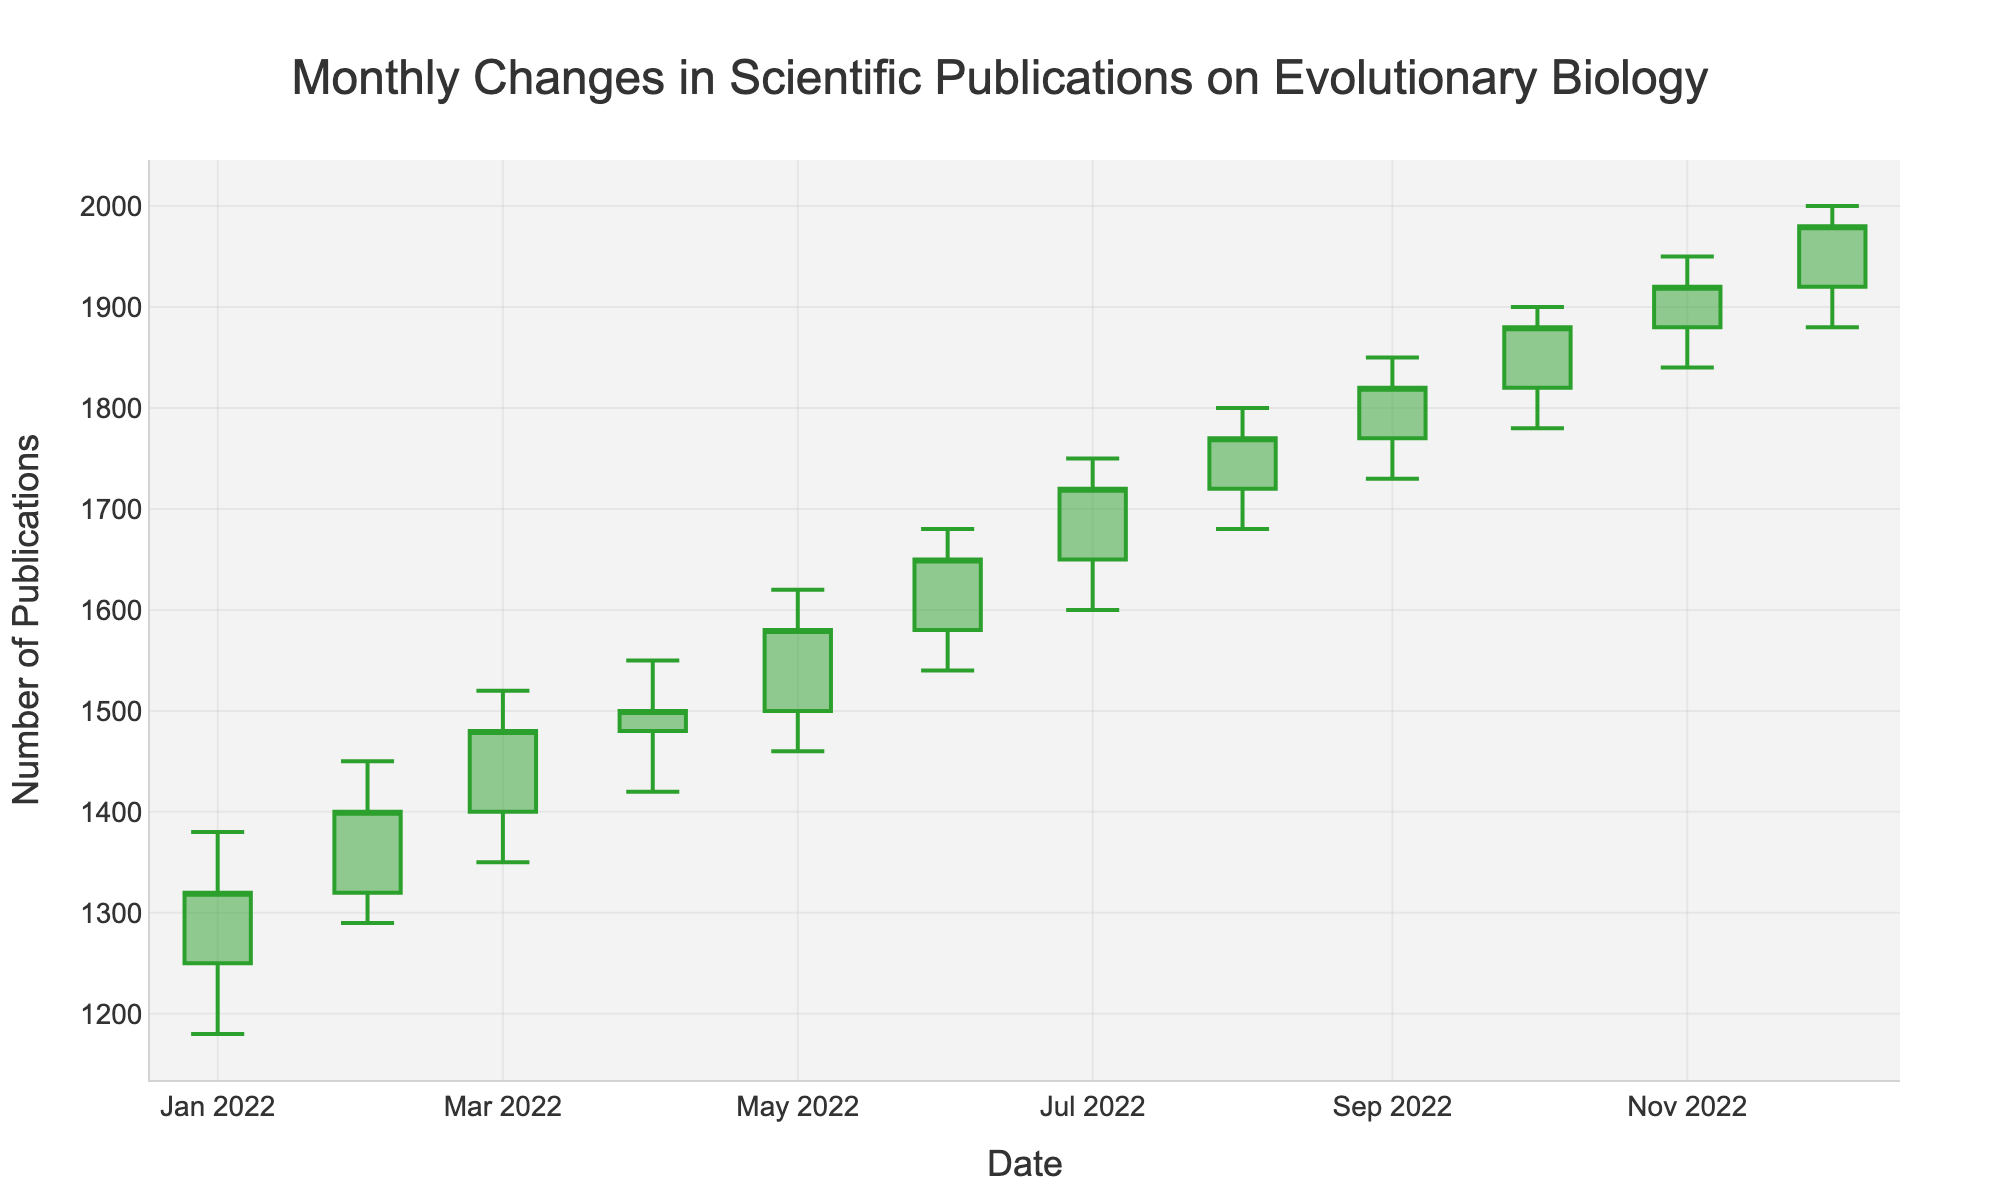How many data points are represented in the chart? The chart shows monthly changes for the year 2022. Since there are 12 months in a year and data for each month is represented, there are 12 data points.
Answer: 12 What is the highest number of publications recorded? The highest point on the chart occurs in December 2022, where the high value is 2000.
Answer: 2000 In what month did the number of publications have the largest increase from the open to close values? By examining the difference between open and close values month-by-month: 
Jan (1320-1250=70), 
Feb (1400-1320=80), 
Mar (1480-1400=80), 
Apr (1500-1480=20), 
May (1580-1500=80), 
Jun (1650-1580=70), 
Jul (1720-1650=70), 
Aug (1770-1720=50), 
Sep (1820-1770=50), 
Oct (1880-1820=60), 
Nov (1920-1880=40), 
Dec (1980-1920=60).
The biggest increase occurs in February, March, and May with an increase of 80 publications.
Answer: February, March, May Which month had the lowest number of publications recorded? The lowest value on the chart is observed in January 2022, where the low value is 1180.
Answer: January What is the overall trend in the number of scientific publications from January to December 2022? The chart shows a general upward trend from January to December 2022, with the close value of each month being higher than the open value of the previous month.
Answer: Upward trend How many months have the closing value higher than the opening value? By checking each month's opening and closing values: 
Jan (1320 > 1250), 
Feb (1400 > 1320), 
Mar (1480 > 1400), 
Apr (1500 > 1480), 
May (1580 > 1500), 
Jun (1650 > 1580), 
Jul (1720 > 1650), 
Aug (1770 > 1720), 
Sep (1820 > 1770), 
Oct (1880 > 1820), 
Nov (1920 > 1880), 
Dec (1980 > 1920).
All 12 months have the closing value higher than the opening value.
Answer: 12 Which month had the smallest range between the highest and lowest number of publications? Calculate the range for each month: 
Jan (1380-1180=200), 
Feb (1450-1290=160), 
Mar (1520-1350=170), 
Apr (1550-1420=130), 
May (1620-1460=160), 
Jun (1680-1540=140), 
Jul (1750-1600=150), 
Aug (1800-1680=120), 
Sep (1850-1730=120), 
Oct (1900-1780=120), 
Nov (1950-1840=110), 
Dec (2000-1880=120). 
November has the smallest range of 110 publications.
Answer: November What is the average closing value over the year? Sum of closing values: 
1320 (Jan) + 1400 (Feb) + 1480 (Mar) + 1500 (Apr) + 1580 (May) + 1650 (Jun) + 1720 (Jul) + 1770 (Aug) + 1820 (Sep) + 1880 (Oct) + 1920 (Nov) + 1980 (Dec) = 20020. 
Divide by 12 months: 20020/12 = 1668
Answer: 1668 Compare the closing values of January and December. By how much did the number of publications increase over the year? The closing value in January is 1320, and in December it is 1980. The increase is calculated as 1980 - 1320 = 660.
Answer: 660 